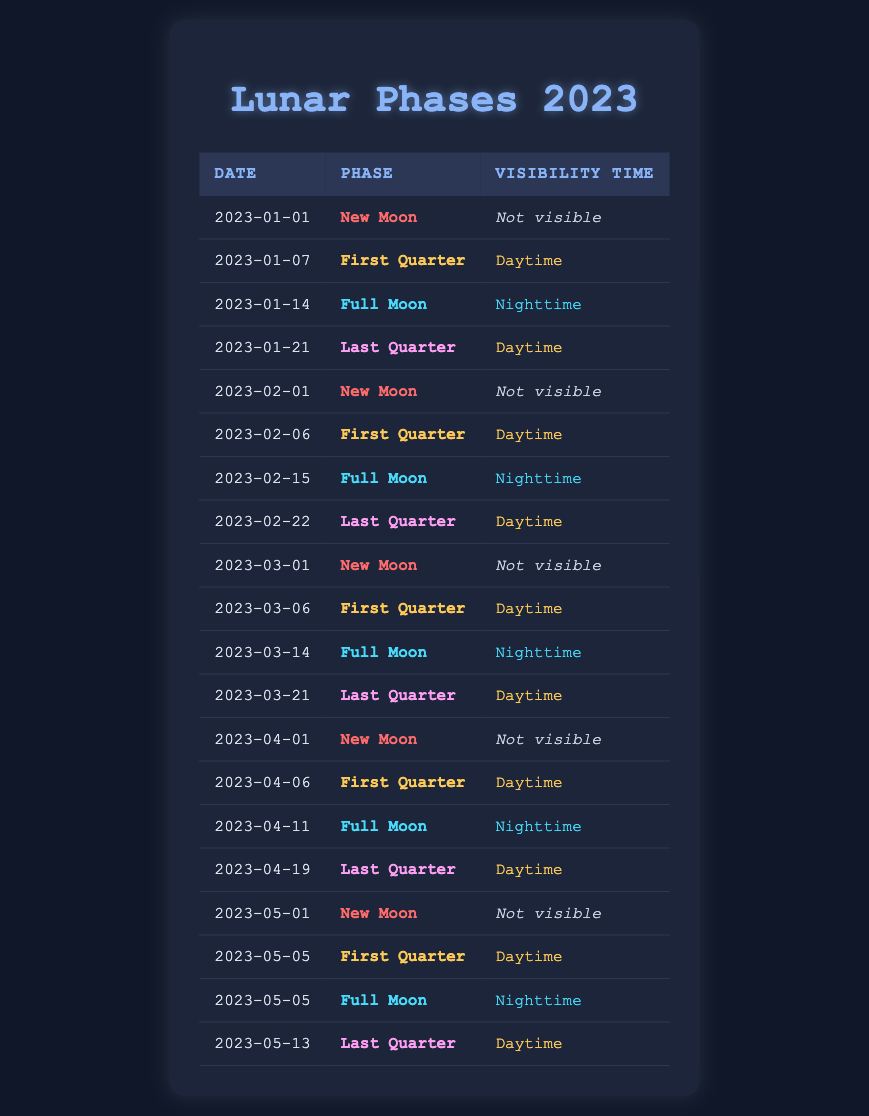What is the visibility time for the Full Moon on January 14, 2023? The table shows that the phase for January 14, 2023, is "Full Moon," and the visibility time is listed as "Nighttime."
Answer: Nighttime How many New Moons are there in 2023? To find the number of New Moons, we can count the rows where the phase is "New Moon." The dates are January 1, February 1, March 1, April 1, and May 1, totaling 5 New Moons.
Answer: 5 On which dates does the Last Quarter phase occur? The table shows Last Quarter phases on January 21, February 22, March 21, April 19, and May 13. Listing these dates, we find the Last Quarter occurs on these five specific dates.
Answer: January 21, February 22, March 21, April 19, May 13 Is the First Quarter phase visible at nighttime? By examining the table, we see the visibility time for all First Quarter phases (January 7, February 6, March 6, April 6, May 5) is "Daytime." Thus, the answer is no.
Answer: No What is the average visibility time for the Full Moon phases in 2023? There are three Full Moons on January 14, February 15, and April 11, and all are visible at "Nighttime." Since all Full Moon phases are "Nighttime," the average visibility time remains "Nighttime."
Answer: Nighttime When is the first Full Moon of the year 2023? The first Full Moon in the table is on January 14, 2023, when looking for the earliest date associated with the Full Moon phase.
Answer: January 14, 2023 How many total phases are listed in the table? The count of all rows in the table indicates there are 17 total lunar phases listed throughout the year 2023.
Answer: 17 Is there a Full Moon that is not visible at daytime? According to the table, none of the Full Moon phases have visibility times listed as "Daytime," which indicates that all are visible at "Nighttime." Thus, the answer is yes.
Answer: Yes What is the visibility time for the First Quarter on March 6, 2023? The table indicates that the phase on March 6, 2023, is "First Quarter," and the visibility time is "Daytime."
Answer: Daytime 